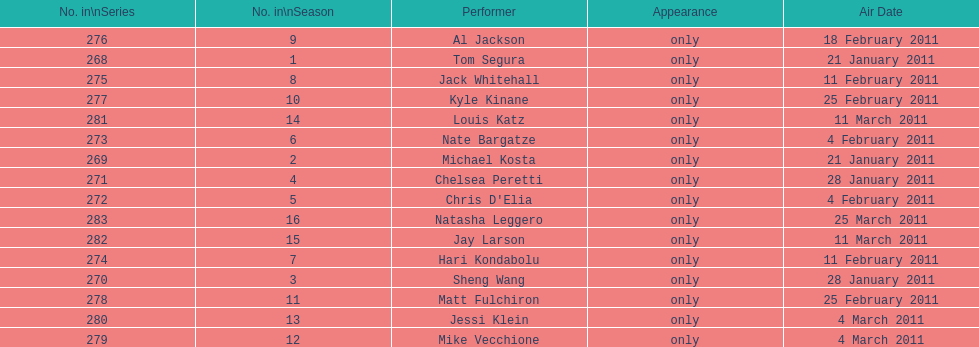Did al jackson air before or after kyle kinane? Before. 